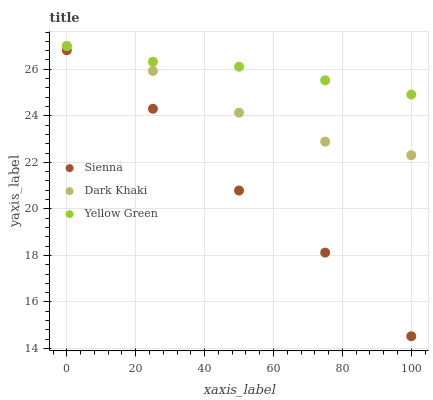Does Sienna have the minimum area under the curve?
Answer yes or no. Yes. Does Yellow Green have the maximum area under the curve?
Answer yes or no. Yes. Does Dark Khaki have the minimum area under the curve?
Answer yes or no. No. Does Dark Khaki have the maximum area under the curve?
Answer yes or no. No. Is Yellow Green the smoothest?
Answer yes or no. Yes. Is Sienna the roughest?
Answer yes or no. Yes. Is Dark Khaki the smoothest?
Answer yes or no. No. Is Dark Khaki the roughest?
Answer yes or no. No. Does Sienna have the lowest value?
Answer yes or no. Yes. Does Dark Khaki have the lowest value?
Answer yes or no. No. Does Yellow Green have the highest value?
Answer yes or no. Yes. Is Sienna less than Dark Khaki?
Answer yes or no. Yes. Is Yellow Green greater than Sienna?
Answer yes or no. Yes. Does Dark Khaki intersect Yellow Green?
Answer yes or no. Yes. Is Dark Khaki less than Yellow Green?
Answer yes or no. No. Is Dark Khaki greater than Yellow Green?
Answer yes or no. No. Does Sienna intersect Dark Khaki?
Answer yes or no. No. 